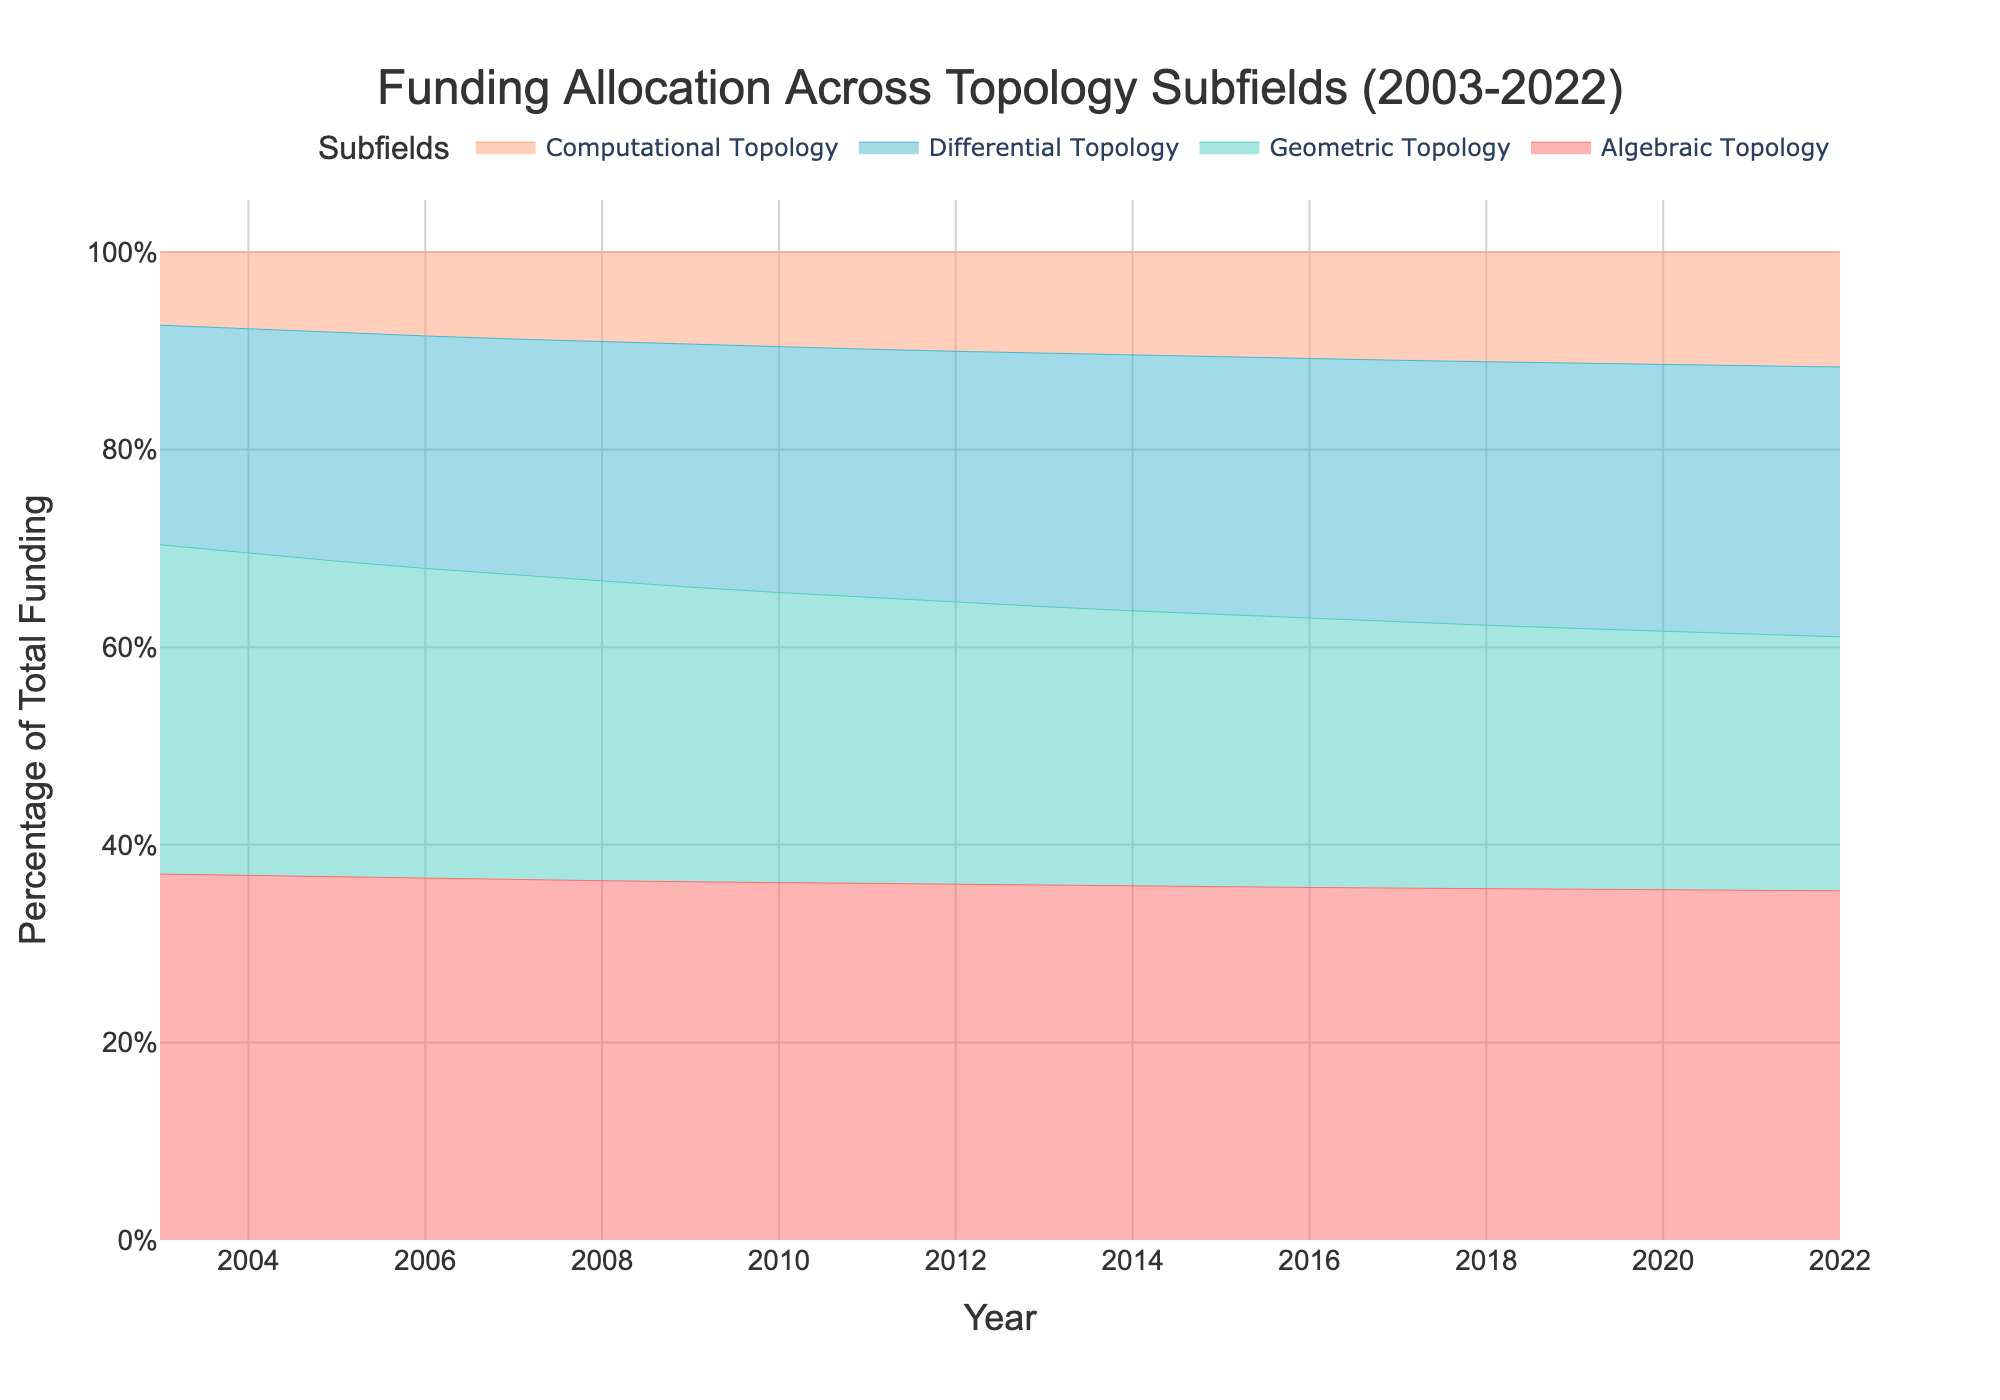What is the title of the chart? The title of the chart is typically located at the top of the figure. In this case, it reads, "Funding Allocation Across Topology Subfields (2003-2022)."
Answer: Funding Allocation Across Topology Subfields (2003-2022) What are the subfields represented in the area chart? The subfields are listed in the legend of the chart. They are Algebraic Topology, Geometric Topology, Differential Topology, and Computational Topology.
Answer: Algebraic Topology, Geometric Topology, Differential Topology, Computational Topology Which subfield appears to have received the highest level of funding over the 20-year period? Based on the area of each subfield's color, Algebraic Topology consistently shows the largest area, indicating the highest level of funding throughout the period from 2003 to 2022.
Answer: Algebraic Topology What was the funding amount for Computational Topology in 2007? To find the funding amount for Computational Topology in 2007, you would look at that year on the x-axis and trace vertically to the color representing Computational Topology. The hover template for this field can provide the exact figure, which is 140,000 USD.
Answer: 140,000 USD How has the percentage of total funding allocated to Differential Topology changed from 2003 to 2022? To determine the change in funding allocation percentage, compare the areas for Differential Topology at the beginning (2003) and end (2022) of the period. The chart stacks the areas in such a way that you can see Differential Topology's percentage has been steadily increasing from 2003 to 2022.
Answer: Increased In which years did Geometric Topology receive equal or more funding than Differential Topology? By comparing the colored areas of Geometric Topology and Differential Topology over the years, you can see where the two areas overlap or Geometric Topology surpasses Differential Topology. This occurs continuously from 2003 to around 2009.
Answer: 2003-2009 Between 2010 and 2020, which subfield saw the most significant growth in funding allocation percentage? To identify the subfield with the most significant growth, compare the vertical growth areas for each subfield between 2010 and 2020. Differential Topology shows the most substantial increase in this period.
Answer: Differential Topology What is the color associated with Algebraic Topology? The color associated with Algebraic Topology can be found by referencing the legend. It is a shade of red (#FF6B6B).
Answer: Red By what margin did the percentage of total funding for Computational Topology grow between 2005 and 2015? First, determine the percentage of total funding for Computational Topology in 2005 and 2015 by comparing the width of its area to the total height. The funding grew from 120,000 USD in 2005 to 220,000 USD in 2015, indicating a significant percentage increase. Calculate the exact initial and final percentages and subtract to find the margin. The margin is roughly proportional to the percentage growth seen visually.
Answer: Significant percentage growth 